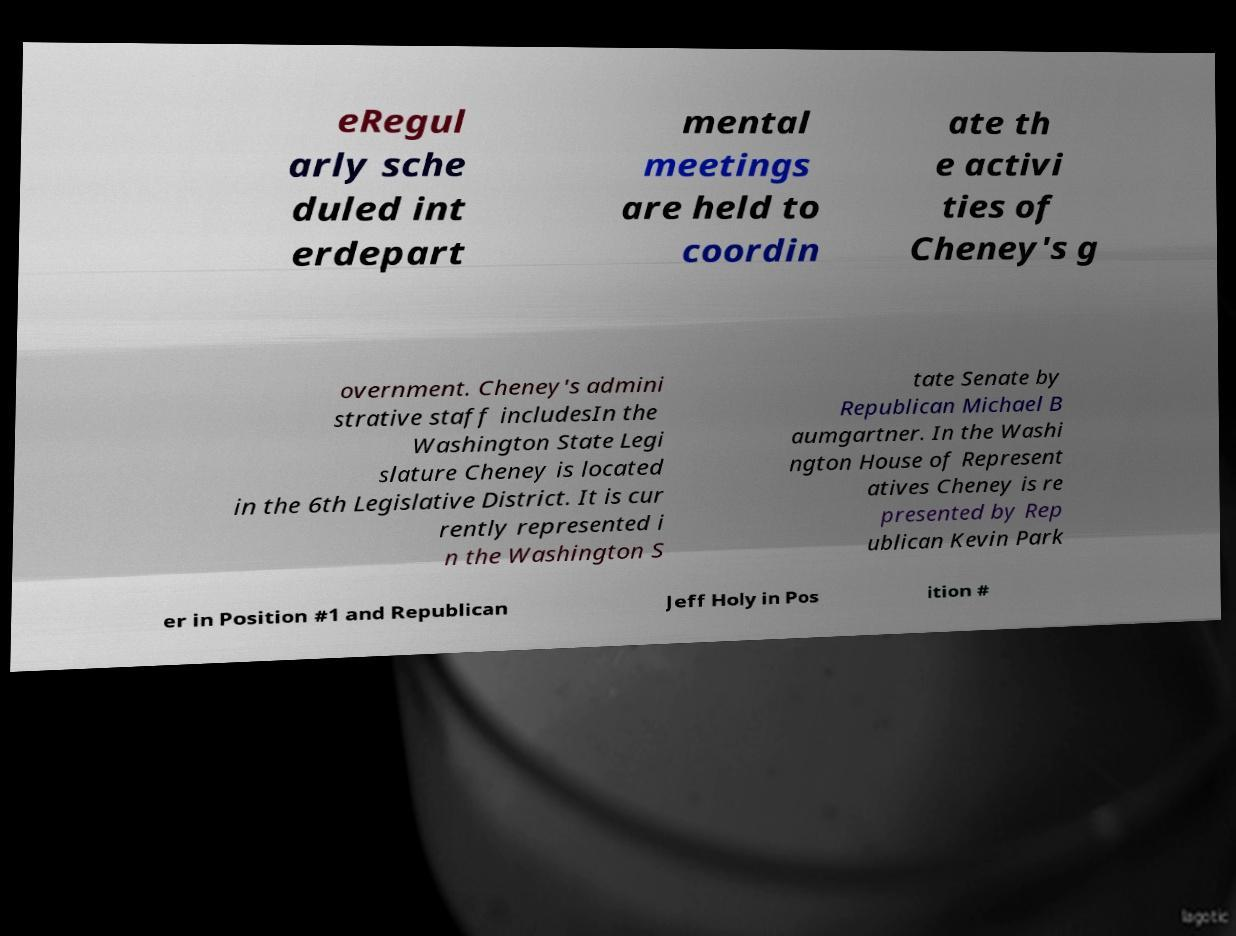For documentation purposes, I need the text within this image transcribed. Could you provide that? eRegul arly sche duled int erdepart mental meetings are held to coordin ate th e activi ties of Cheney's g overnment. Cheney's admini strative staff includesIn the Washington State Legi slature Cheney is located in the 6th Legislative District. It is cur rently represented i n the Washington S tate Senate by Republican Michael B aumgartner. In the Washi ngton House of Represent atives Cheney is re presented by Rep ublican Kevin Park er in Position #1 and Republican Jeff Holy in Pos ition # 